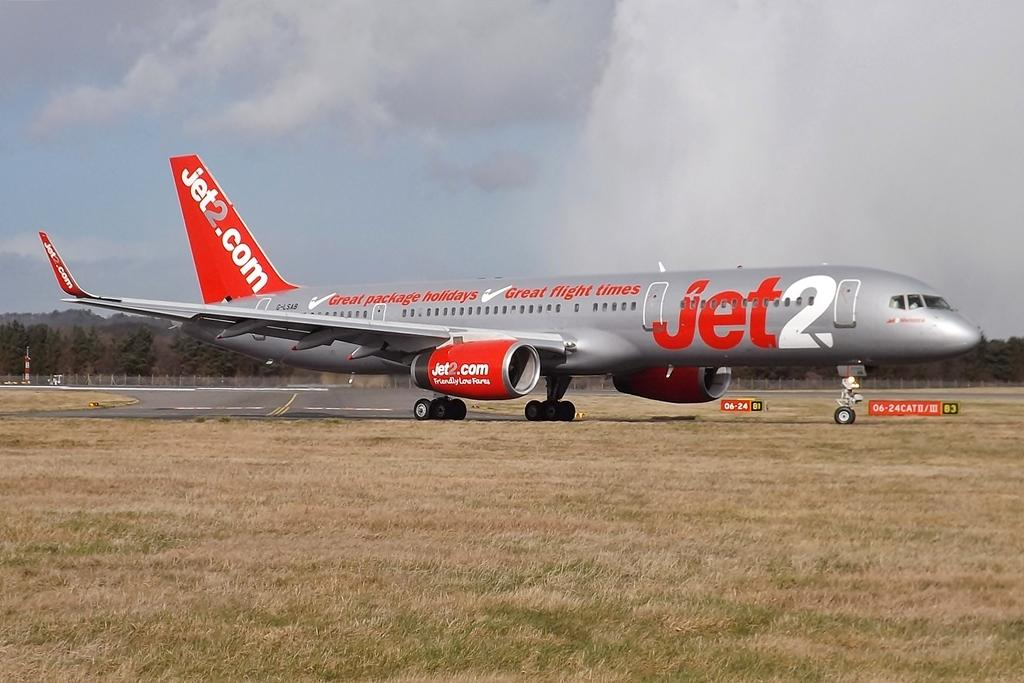<image>
Offer a succinct explanation of the picture presented. An orange and silver airplane has a large Jet2 image on its side. 